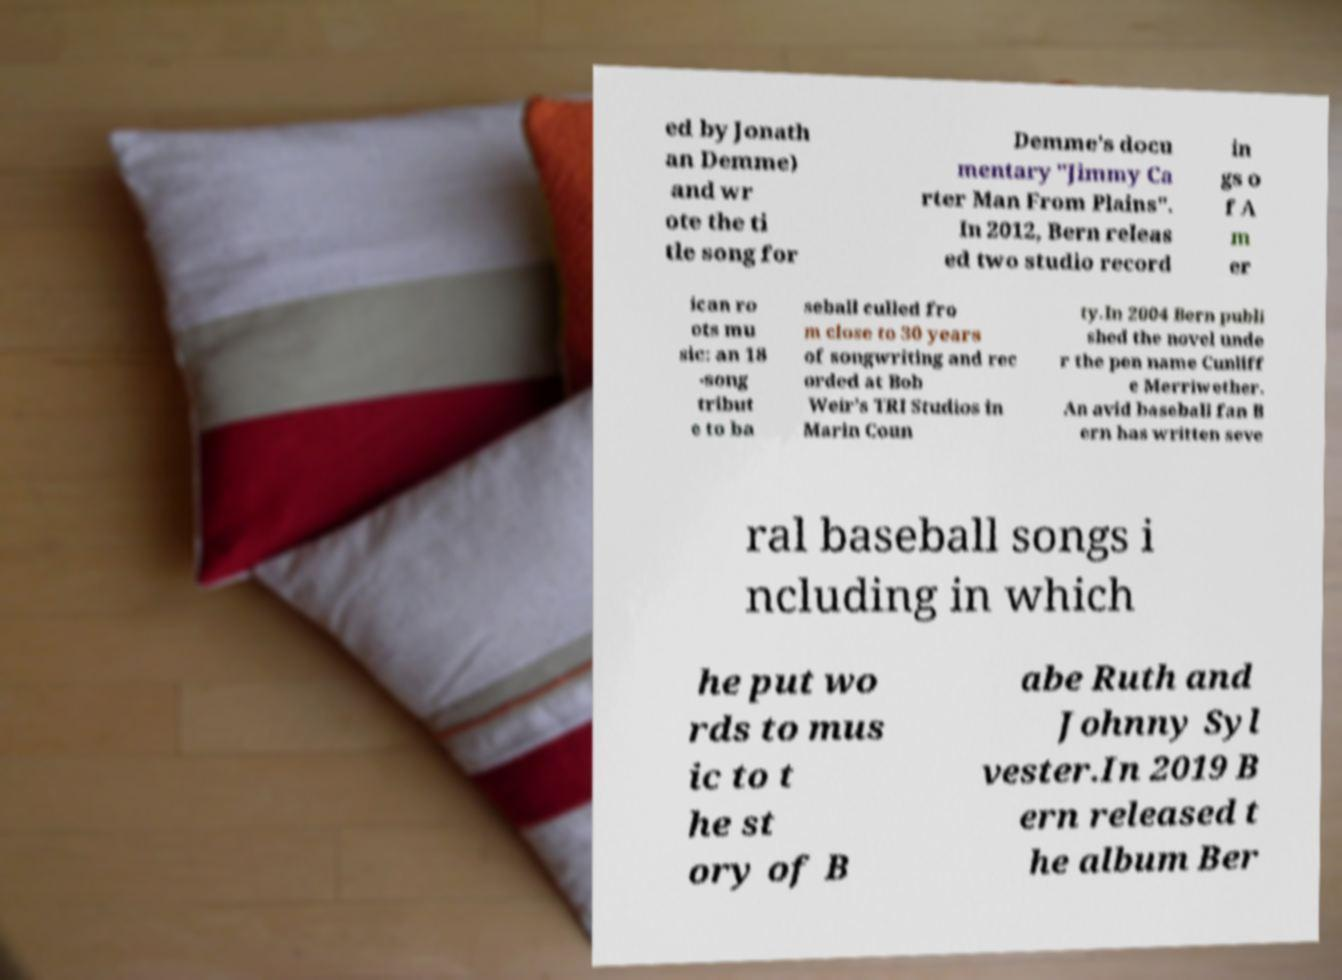Could you assist in decoding the text presented in this image and type it out clearly? ed by Jonath an Demme) and wr ote the ti tle song for Demme's docu mentary "Jimmy Ca rter Man From Plains". In 2012, Bern releas ed two studio record in gs o f A m er ican ro ots mu sic: an 18 -song tribut e to ba seball culled fro m close to 30 years of songwriting and rec orded at Bob Weir’s TRI Studios in Marin Coun ty.In 2004 Bern publi shed the novel unde r the pen name Cunliff e Merriwether. An avid baseball fan B ern has written seve ral baseball songs i ncluding in which he put wo rds to mus ic to t he st ory of B abe Ruth and Johnny Syl vester.In 2019 B ern released t he album Ber 